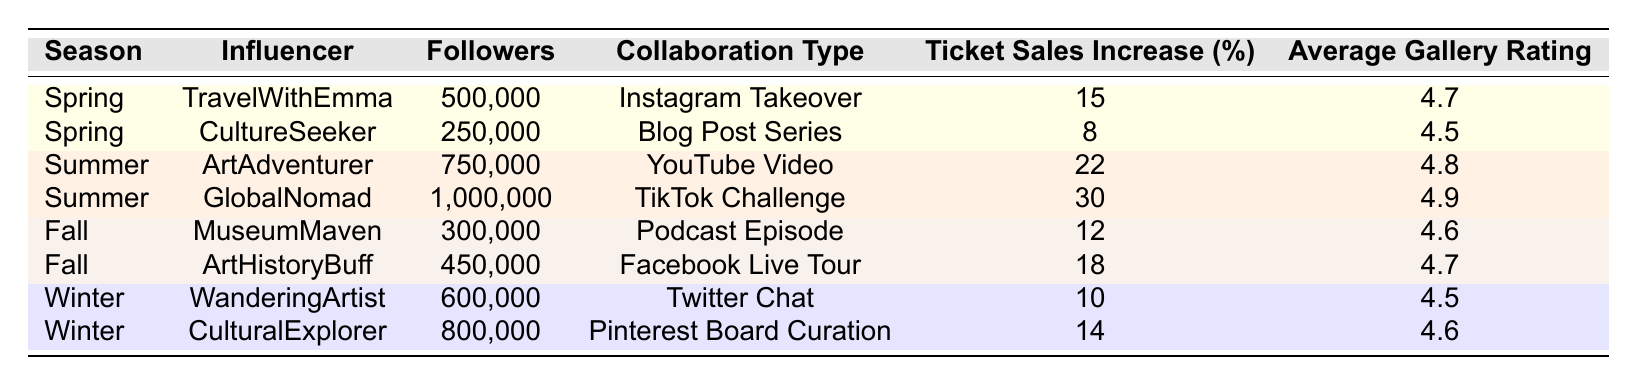What is the total ticket sales increase percentage across all influencers in the Summer season? In the Summer season, the ticket sales increase percentages are 22% from ArtAdventurer and 30% from GlobalNomad. Adding these gives 22 + 30 = 52%.
Answer: 52% Which influencer had the highest ticket sales increase percentage? The highest ticket sales increase percentage is 30%, attributed to GlobalNomad in the Summer season.
Answer: GlobalNomad Was there an influencer in the Fall season that had a higher ticket sales increase percentage than the Winter season? In the Fall season, the ticket sales increase percentages are 12% for MuseumMaven and 18% for ArtHistoryBuff. In the Winter season, they are 10% for WanderingArtist and 14% for CulturalExplorer. ArtHistoryBuff's 18% is higher than both Winter values.
Answer: Yes What is the average ticket sales increase percentage for influencers in the Spring season? In Spring, the ticket sales increases are 15% for TravelWithEmma and 8% for CultureSeeker. The average is calculated as (15 + 8) / 2 = 11.5%.
Answer: 11.5% Which season had the best average gallery rating from influencers? The average gallery ratings by season are: Spring (4.6), Summer (4.85), Fall (4.65), and Winter (4.55). The Summer season has the highest average rating at 4.85.
Answer: Summer Is there any influencer in the Winter season whose average gallery rating is above 4.5? The average gallery ratings for Winter influencers are 4.5 for WanderingArtist and 4.6 for CulturalExplorer. CulturallyExplorer has a rating above 4.5.
Answer: Yes What is the difference in ticket sales increase percentage between the highest and lowest influencers across all seasons? The highest is GlobalNomad at 30% and the lowest is CultureSeeker at 8%. The difference is 30 - 8 = 22%.
Answer: 22% Based on the table, how many influencers had ticket sales increases below 15%? The influencers with ticket sales increases below 15% are CultureSeeker (8%), MuseumMaven (12%), and WanderingArtist (10%). This totals three influencers.
Answer: 3 What is the total number of followers for influencers collaborating in the Spring season? In Spring, TravelWithEmma has 500,000 followers and CultureSeeker has 250,000 followers. Summing these gives 500,000 + 250,000 = 750,000 followers.
Answer: 750,000 Which collaboration type yielded the highest average gallery rating? The average ratings per collaboration type are: Instagram Takeover (4.7), Blog Post Series (4.5), YouTube Video (4.8), TikTok Challenge (4.9), Podcast Episode (4.6), Facebook Live Tour (4.7), Twitter Chat (4.5), Pinterest Board Curation (4.6). The TikTok Challenge has the highest average rating at 4.9.
Answer: TikTok Challenge 